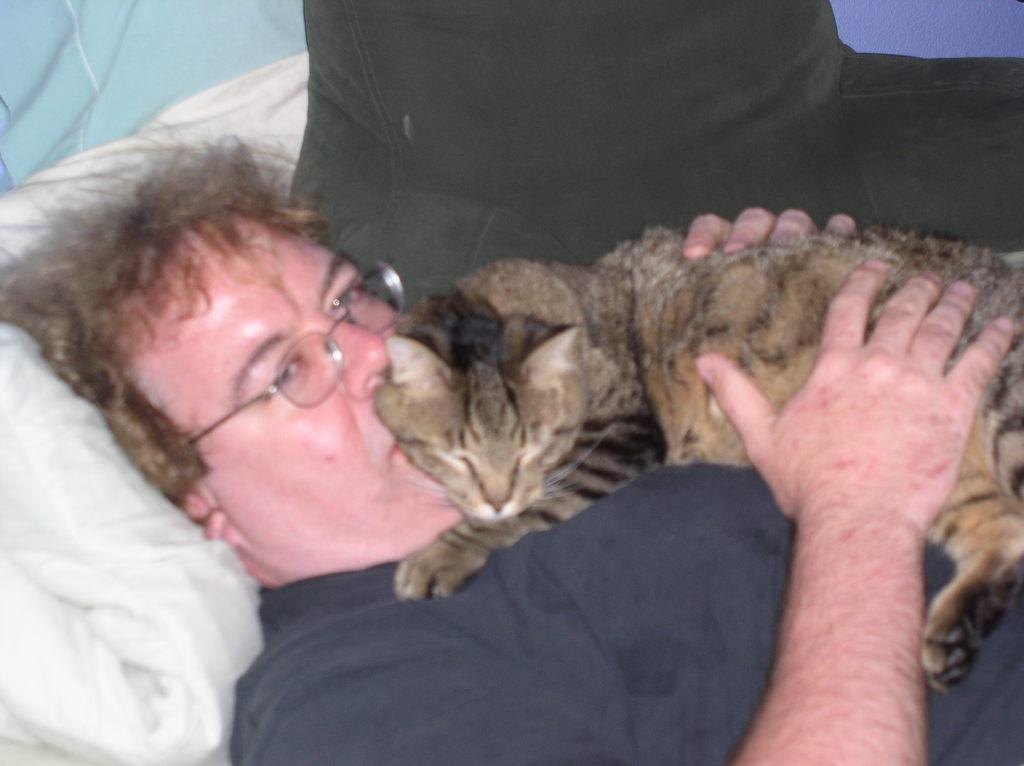What is the main subject of the image? There is a person in the image. What is the person doing in the image? The person is lying on a couch. Is there any other living creature in the image besides the person? Yes, there is a cat in the image. How is the cat positioned in relation to the person? The cat is on the person, and the person is holding the cat with their hands. What type of pickle is the person using to play with the cat in the image? There is no pickle present in the image, and the person is not using any object to play with the cat. 